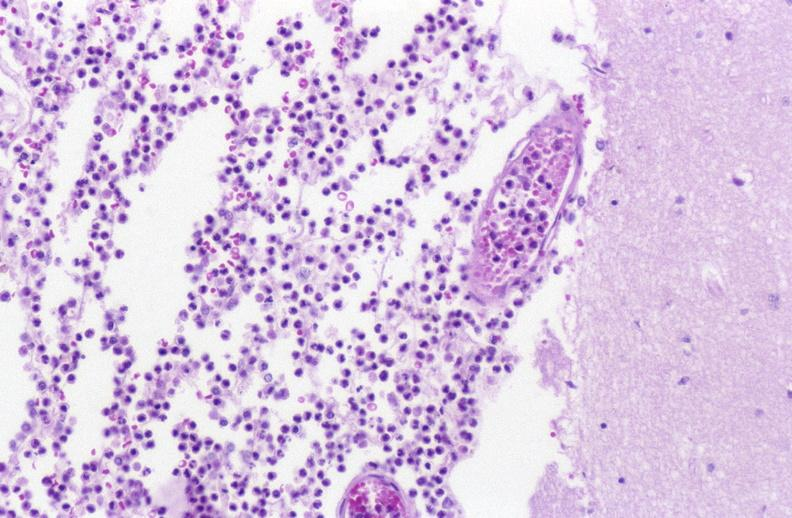does metastatic adenocarcinoma show bacterial meningitis?
Answer the question using a single word or phrase. No 